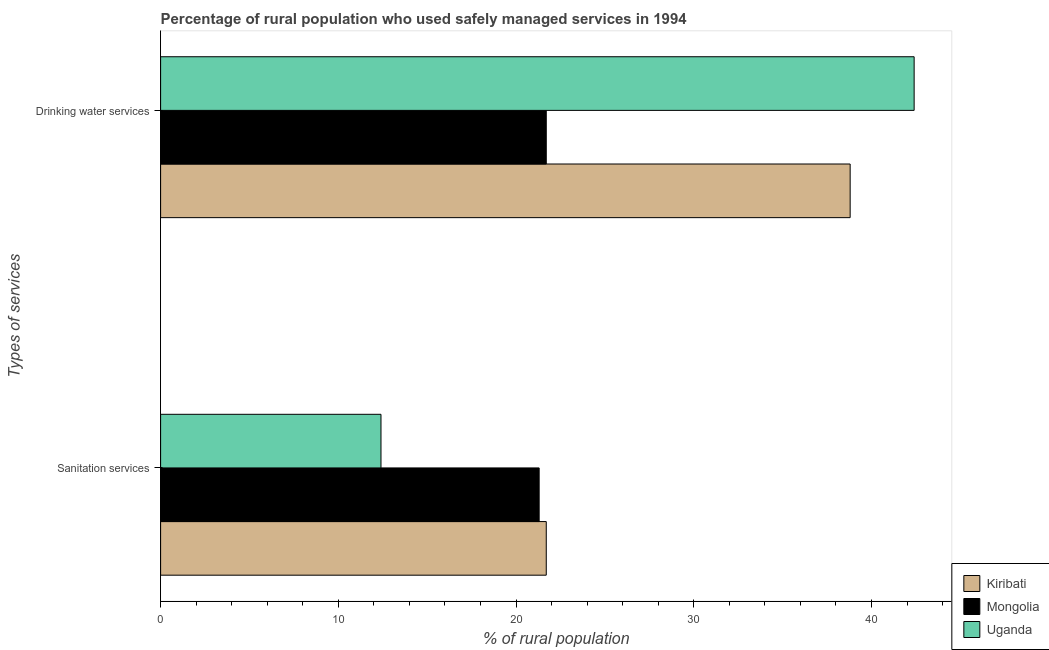Are the number of bars per tick equal to the number of legend labels?
Give a very brief answer. Yes. Are the number of bars on each tick of the Y-axis equal?
Offer a terse response. Yes. What is the label of the 1st group of bars from the top?
Make the answer very short. Drinking water services. What is the percentage of rural population who used sanitation services in Mongolia?
Offer a terse response. 21.3. Across all countries, what is the maximum percentage of rural population who used drinking water services?
Make the answer very short. 42.4. Across all countries, what is the minimum percentage of rural population who used drinking water services?
Keep it short and to the point. 21.7. In which country was the percentage of rural population who used sanitation services maximum?
Make the answer very short. Kiribati. In which country was the percentage of rural population who used drinking water services minimum?
Offer a very short reply. Mongolia. What is the total percentage of rural population who used sanitation services in the graph?
Make the answer very short. 55.4. What is the difference between the percentage of rural population who used drinking water services in Uganda and that in Mongolia?
Offer a very short reply. 20.7. What is the difference between the percentage of rural population who used drinking water services in Uganda and the percentage of rural population who used sanitation services in Mongolia?
Your answer should be very brief. 21.1. What is the average percentage of rural population who used sanitation services per country?
Provide a short and direct response. 18.47. What is the difference between the percentage of rural population who used drinking water services and percentage of rural population who used sanitation services in Uganda?
Your response must be concise. 30. What is the ratio of the percentage of rural population who used drinking water services in Mongolia to that in Uganda?
Give a very brief answer. 0.51. What does the 2nd bar from the top in Drinking water services represents?
Your response must be concise. Mongolia. What does the 3rd bar from the bottom in Drinking water services represents?
Make the answer very short. Uganda. How many bars are there?
Your answer should be very brief. 6. Are the values on the major ticks of X-axis written in scientific E-notation?
Keep it short and to the point. No. Does the graph contain any zero values?
Your response must be concise. No. Does the graph contain grids?
Give a very brief answer. No. Where does the legend appear in the graph?
Make the answer very short. Bottom right. How many legend labels are there?
Your answer should be compact. 3. What is the title of the graph?
Your answer should be very brief. Percentage of rural population who used safely managed services in 1994. What is the label or title of the X-axis?
Your response must be concise. % of rural population. What is the label or title of the Y-axis?
Make the answer very short. Types of services. What is the % of rural population in Kiribati in Sanitation services?
Offer a terse response. 21.7. What is the % of rural population in Mongolia in Sanitation services?
Provide a succinct answer. 21.3. What is the % of rural population of Uganda in Sanitation services?
Keep it short and to the point. 12.4. What is the % of rural population in Kiribati in Drinking water services?
Offer a very short reply. 38.8. What is the % of rural population of Mongolia in Drinking water services?
Your response must be concise. 21.7. What is the % of rural population in Uganda in Drinking water services?
Make the answer very short. 42.4. Across all Types of services, what is the maximum % of rural population of Kiribati?
Your answer should be very brief. 38.8. Across all Types of services, what is the maximum % of rural population in Mongolia?
Your answer should be very brief. 21.7. Across all Types of services, what is the maximum % of rural population in Uganda?
Offer a terse response. 42.4. Across all Types of services, what is the minimum % of rural population of Kiribati?
Give a very brief answer. 21.7. Across all Types of services, what is the minimum % of rural population of Mongolia?
Offer a terse response. 21.3. Across all Types of services, what is the minimum % of rural population of Uganda?
Give a very brief answer. 12.4. What is the total % of rural population in Kiribati in the graph?
Your answer should be compact. 60.5. What is the total % of rural population in Mongolia in the graph?
Provide a short and direct response. 43. What is the total % of rural population in Uganda in the graph?
Offer a terse response. 54.8. What is the difference between the % of rural population of Kiribati in Sanitation services and that in Drinking water services?
Provide a short and direct response. -17.1. What is the difference between the % of rural population in Uganda in Sanitation services and that in Drinking water services?
Offer a terse response. -30. What is the difference between the % of rural population in Kiribati in Sanitation services and the % of rural population in Mongolia in Drinking water services?
Your answer should be compact. 0. What is the difference between the % of rural population in Kiribati in Sanitation services and the % of rural population in Uganda in Drinking water services?
Offer a terse response. -20.7. What is the difference between the % of rural population in Mongolia in Sanitation services and the % of rural population in Uganda in Drinking water services?
Keep it short and to the point. -21.1. What is the average % of rural population in Kiribati per Types of services?
Offer a very short reply. 30.25. What is the average % of rural population of Mongolia per Types of services?
Keep it short and to the point. 21.5. What is the average % of rural population of Uganda per Types of services?
Ensure brevity in your answer.  27.4. What is the difference between the % of rural population of Mongolia and % of rural population of Uganda in Sanitation services?
Provide a short and direct response. 8.9. What is the difference between the % of rural population of Mongolia and % of rural population of Uganda in Drinking water services?
Offer a very short reply. -20.7. What is the ratio of the % of rural population in Kiribati in Sanitation services to that in Drinking water services?
Ensure brevity in your answer.  0.56. What is the ratio of the % of rural population in Mongolia in Sanitation services to that in Drinking water services?
Offer a terse response. 0.98. What is the ratio of the % of rural population in Uganda in Sanitation services to that in Drinking water services?
Offer a terse response. 0.29. What is the difference between the highest and the second highest % of rural population in Mongolia?
Give a very brief answer. 0.4. What is the difference between the highest and the second highest % of rural population in Uganda?
Your answer should be compact. 30. What is the difference between the highest and the lowest % of rural population in Kiribati?
Offer a terse response. 17.1. What is the difference between the highest and the lowest % of rural population in Uganda?
Give a very brief answer. 30. 